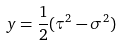<formula> <loc_0><loc_0><loc_500><loc_500>y = \frac { 1 } { 2 } ( \tau ^ { 2 } - \sigma ^ { 2 } )</formula> 